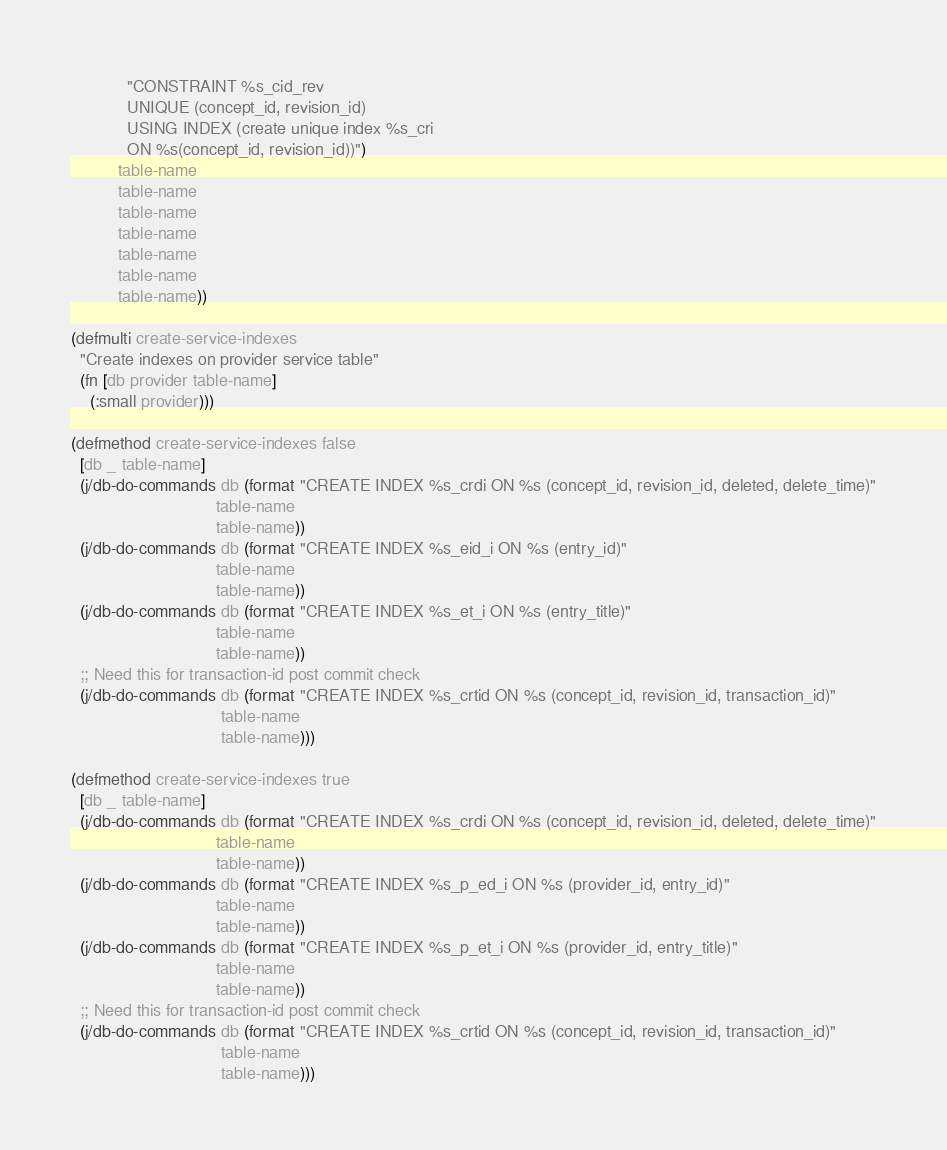Convert code to text. <code><loc_0><loc_0><loc_500><loc_500><_Clojure_>            "CONSTRAINT %s_cid_rev
            UNIQUE (concept_id, revision_id)
            USING INDEX (create unique index %s_cri
            ON %s(concept_id, revision_id))")
          table-name
          table-name
          table-name
          table-name
          table-name
          table-name
          table-name))

(defmulti create-service-indexes
  "Create indexes on provider service table"
  (fn [db provider table-name]
    (:small provider)))

(defmethod create-service-indexes false
  [db _ table-name]
  (j/db-do-commands db (format "CREATE INDEX %s_crdi ON %s (concept_id, revision_id, deleted, delete_time)"
                               table-name
                               table-name))
  (j/db-do-commands db (format "CREATE INDEX %s_eid_i ON %s (entry_id)"
                               table-name
                               table-name))
  (j/db-do-commands db (format "CREATE INDEX %s_et_i ON %s (entry_title)"
                               table-name
                               table-name))
  ;; Need this for transaction-id post commit check
  (j/db-do-commands db (format "CREATE INDEX %s_crtid ON %s (concept_id, revision_id, transaction_id)"
                                table-name
                                table-name)))

(defmethod create-service-indexes true
  [db _ table-name]
  (j/db-do-commands db (format "CREATE INDEX %s_crdi ON %s (concept_id, revision_id, deleted, delete_time)"
                               table-name
                               table-name))
  (j/db-do-commands db (format "CREATE INDEX %s_p_ed_i ON %s (provider_id, entry_id)"
                               table-name
                               table-name))
  (j/db-do-commands db (format "CREATE INDEX %s_p_et_i ON %s (provider_id, entry_title)"
                               table-name
                               table-name))
  ;; Need this for transaction-id post commit check
  (j/db-do-commands db (format "CREATE INDEX %s_crtid ON %s (concept_id, revision_id, transaction_id)"
                                table-name
                                table-name)))
</code> 